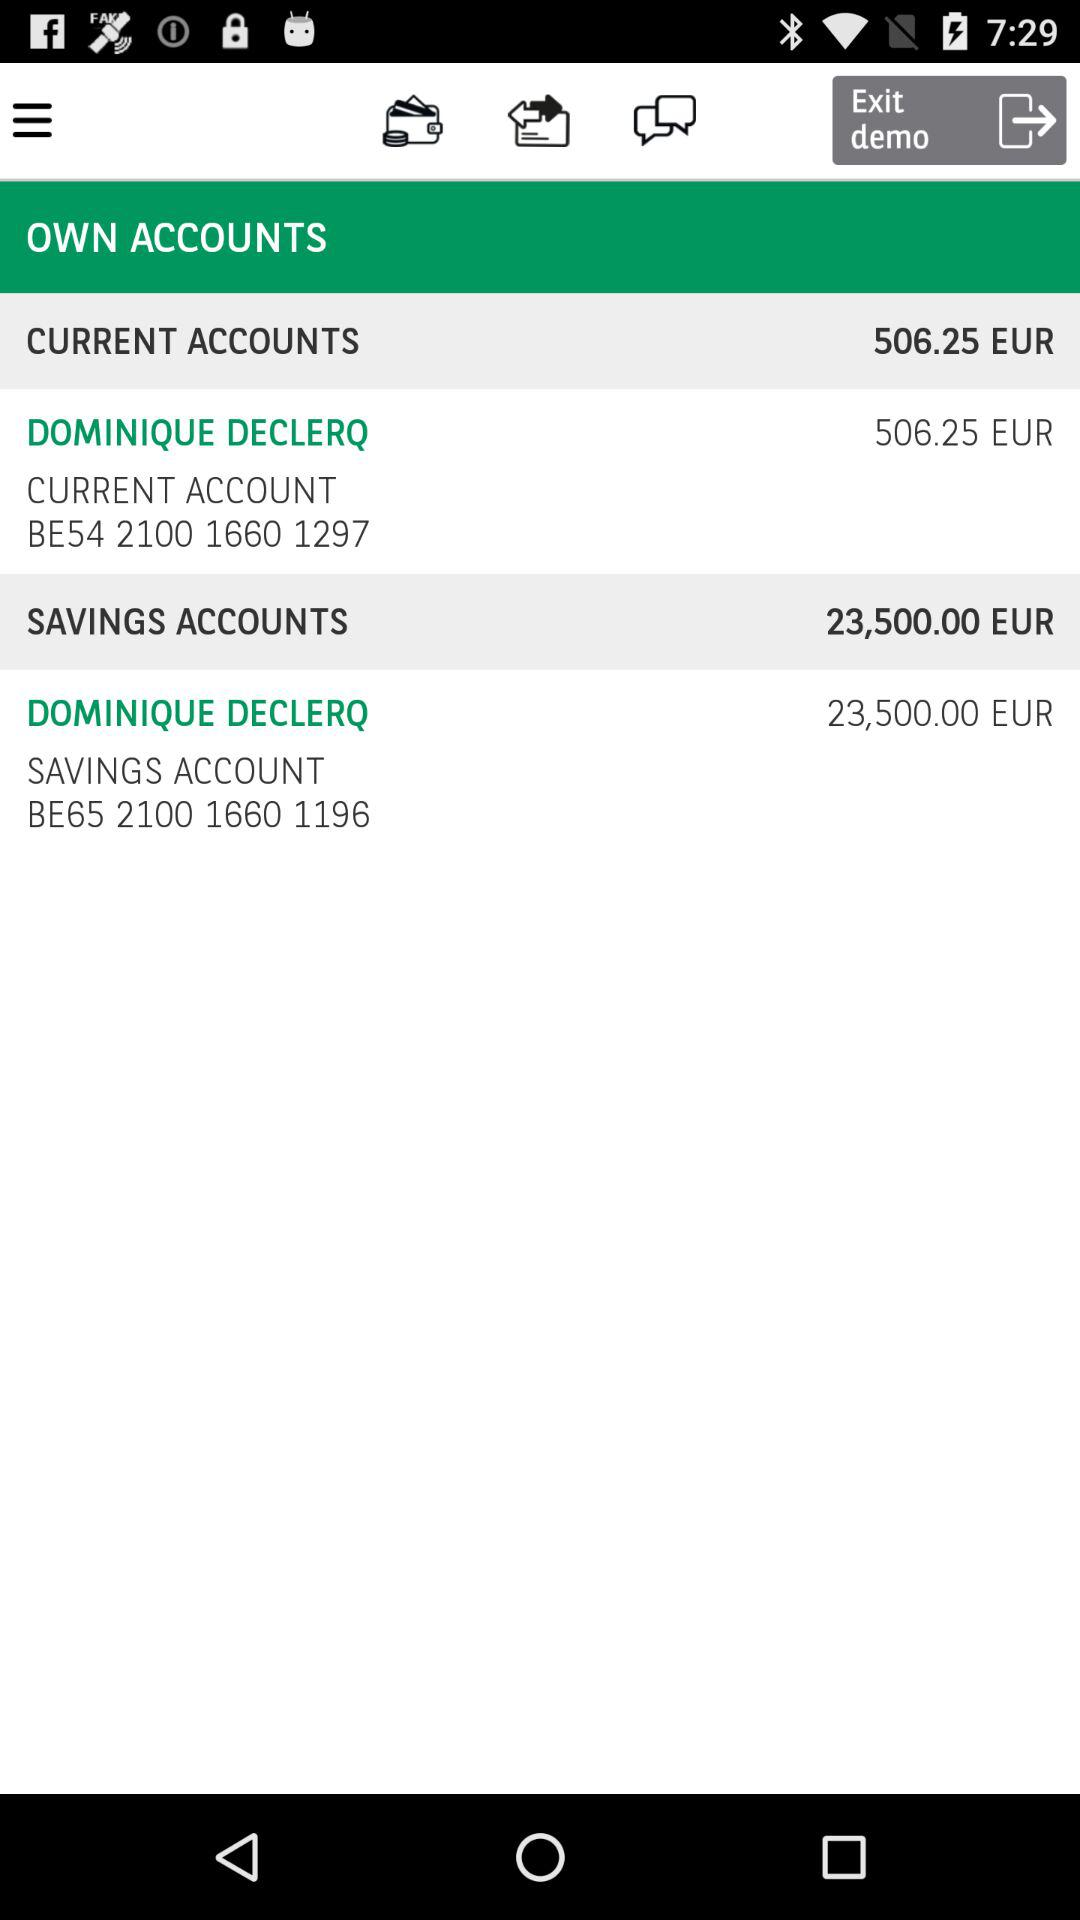How many accounts does Dominique Declerq have?
Answer the question using a single word or phrase. 2 